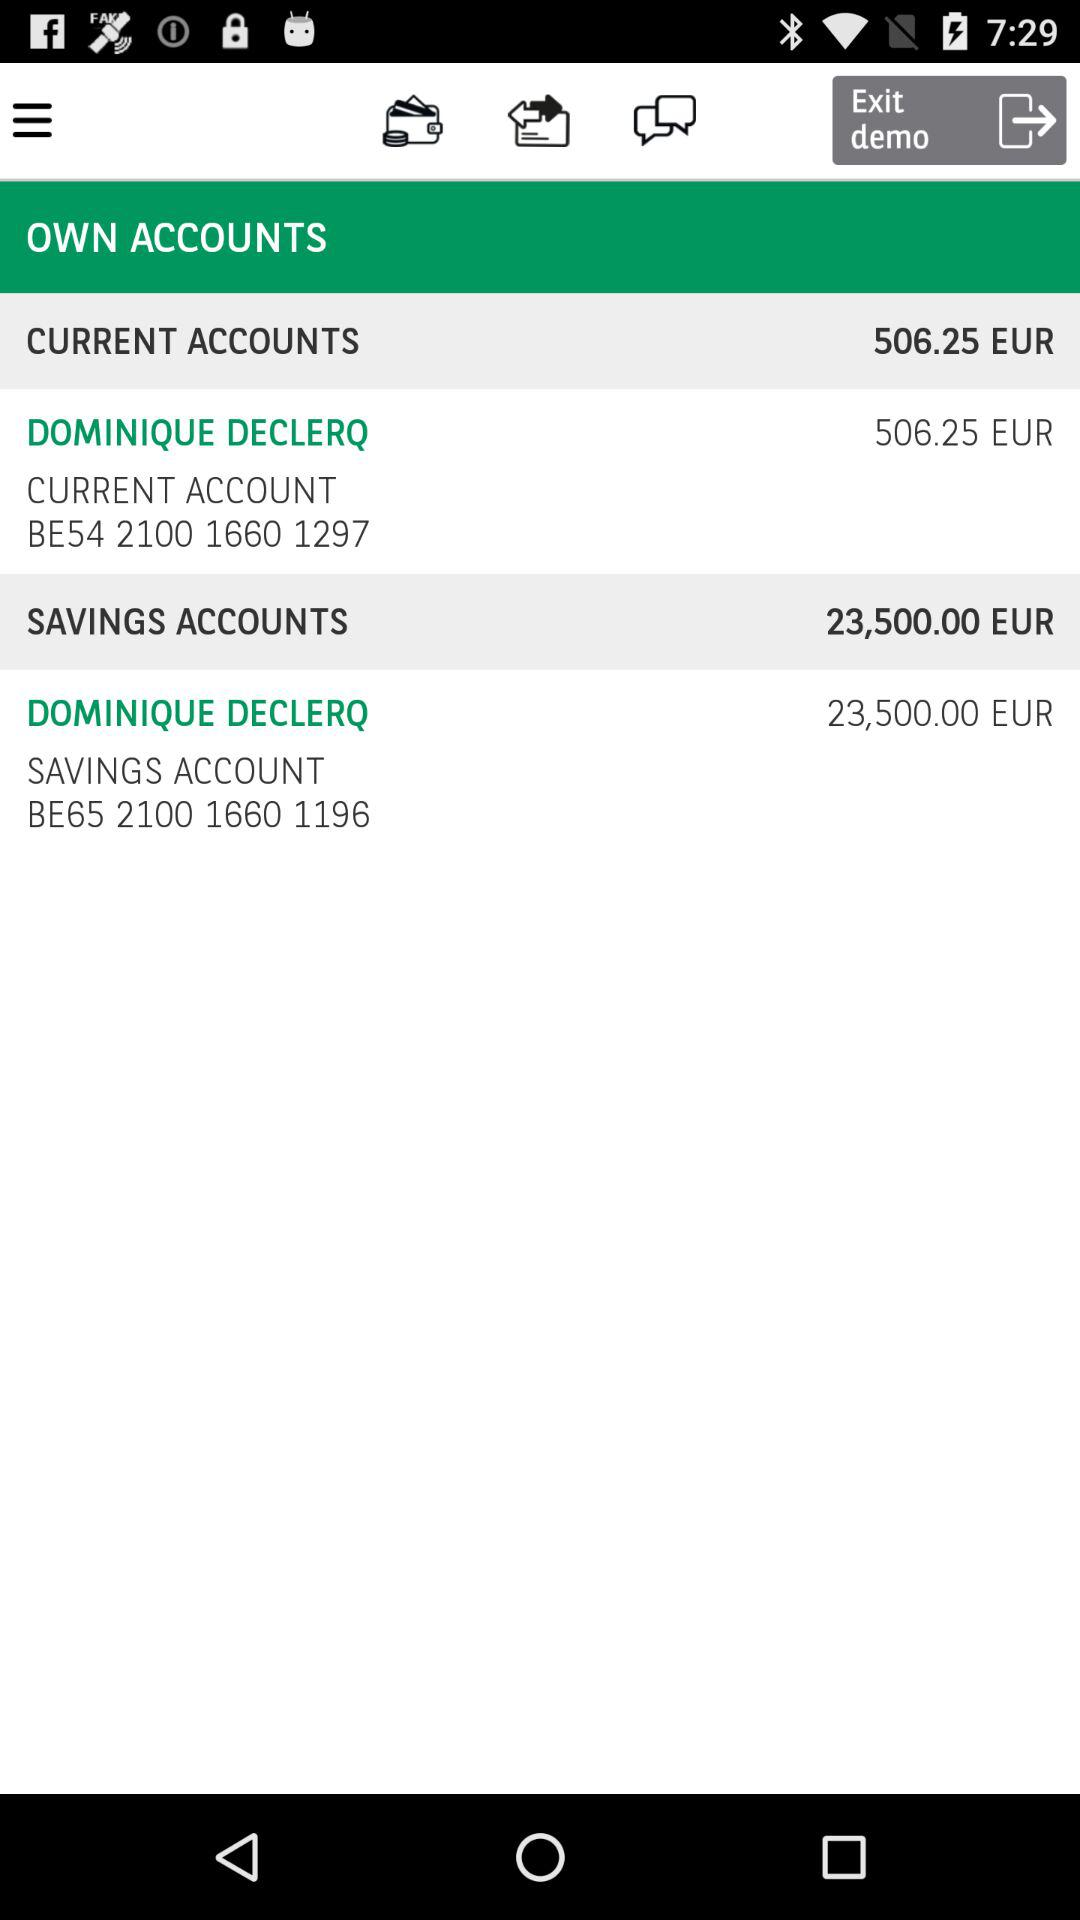How many accounts does Dominique Declerq have?
Answer the question using a single word or phrase. 2 